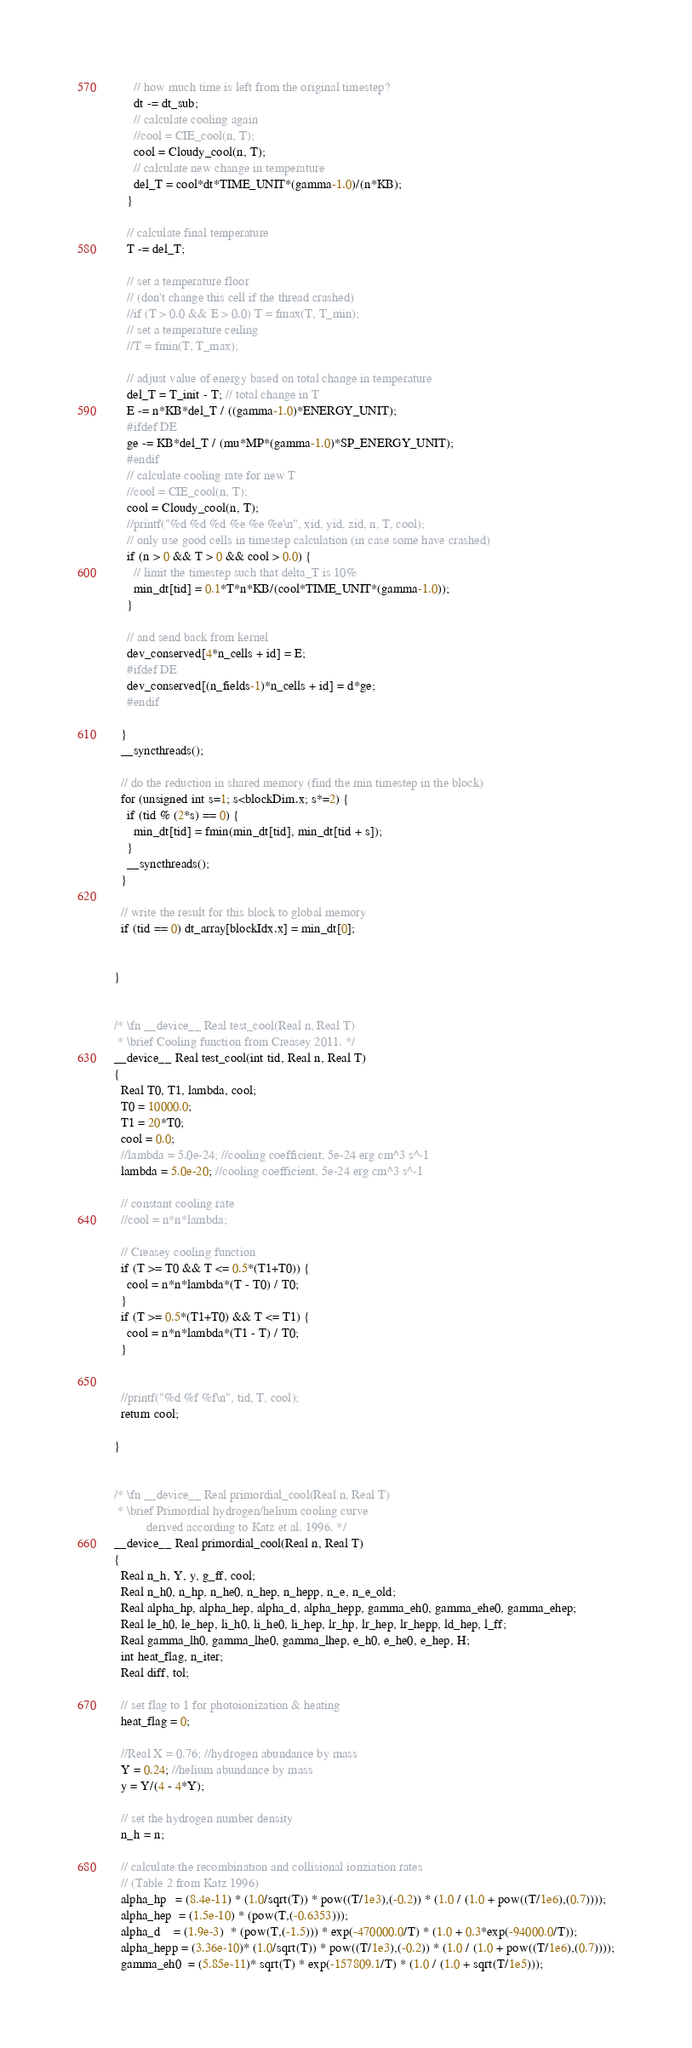<code> <loc_0><loc_0><loc_500><loc_500><_Cuda_>      // how much time is left from the original timestep?
      dt -= dt_sub;
      // calculate cooling again
      //cool = CIE_cool(n, T);
      cool = Cloudy_cool(n, T);
      // calculate new change in temperature
      del_T = cool*dt*TIME_UNIT*(gamma-1.0)/(n*KB);
    }

    // calculate final temperature
    T -= del_T;

    // set a temperature floor
    // (don't change this cell if the thread crashed)
    //if (T > 0.0 && E > 0.0) T = fmax(T, T_min);
    // set a temperature ceiling 
    //T = fmin(T, T_max);

    // adjust value of energy based on total change in temperature
    del_T = T_init - T; // total change in T
    E -= n*KB*del_T / ((gamma-1.0)*ENERGY_UNIT);
    #ifdef DE
    ge -= KB*del_T / (mu*MP*(gamma-1.0)*SP_ENERGY_UNIT);
    #endif
    // calculate cooling rate for new T
    //cool = CIE_cool(n, T);
    cool = Cloudy_cool(n, T);
    //printf("%d %d %d %e %e %e\n", xid, yid, zid, n, T, cool);
    // only use good cells in timestep calculation (in case some have crashed)
    if (n > 0 && T > 0 && cool > 0.0) {
      // limit the timestep such that delta_T is 10% 
      min_dt[tid] = 0.1*T*n*KB/(cool*TIME_UNIT*(gamma-1.0));
    }

    // and send back from kernel
    dev_conserved[4*n_cells + id] = E;
    #ifdef DE
    dev_conserved[(n_fields-1)*n_cells + id] = d*ge;
    #endif

  }
  __syncthreads();

  // do the reduction in shared memory (find the min timestep in the block)
  for (unsigned int s=1; s<blockDim.x; s*=2) {
    if (tid % (2*s) == 0) {
      min_dt[tid] = fmin(min_dt[tid], min_dt[tid + s]);
    }
    __syncthreads();
  }

  // write the result for this block to global memory
  if (tid == 0) dt_array[blockIdx.x] = min_dt[0];
  

}


/* \fn __device__ Real test_cool(Real n, Real T)
 * \brief Cooling function from Creasey 2011. */
__device__ Real test_cool(int tid, Real n, Real T)
{
  Real T0, T1, lambda, cool;
  T0 = 10000.0;
  T1 = 20*T0;
  cool = 0.0;
  //lambda = 5.0e-24; //cooling coefficient, 5e-24 erg cm^3 s^-1
  lambda = 5.0e-20; //cooling coefficient, 5e-24 erg cm^3 s^-1

  // constant cooling rate 
  //cool = n*n*lambda;

  // Creasey cooling function
  if (T >= T0 && T <= 0.5*(T1+T0)) {
    cool = n*n*lambda*(T - T0) / T0;
  }
  if (T >= 0.5*(T1+T0) && T <= T1) {
    cool = n*n*lambda*(T1 - T) / T0;
  }
 

  //printf("%d %f %f\n", tid, T, cool);
  return cool;

}


/* \fn __device__ Real primordial_cool(Real n, Real T)
 * \brief Primordial hydrogen/helium cooling curve 
          derived according to Katz et al. 1996. */
__device__ Real primordial_cool(Real n, Real T)
{
  Real n_h, Y, y, g_ff, cool;
  Real n_h0, n_hp, n_he0, n_hep, n_hepp, n_e, n_e_old; 
  Real alpha_hp, alpha_hep, alpha_d, alpha_hepp, gamma_eh0, gamma_ehe0, gamma_ehep;
  Real le_h0, le_hep, li_h0, li_he0, li_hep, lr_hp, lr_hep, lr_hepp, ld_hep, l_ff;
  Real gamma_lh0, gamma_lhe0, gamma_lhep, e_h0, e_he0, e_hep, H;
  int heat_flag, n_iter;
  Real diff, tol;

  // set flag to 1 for photoionization & heating
  heat_flag = 0;

  //Real X = 0.76; //hydrogen abundance by mass
  Y = 0.24; //helium abundance by mass
  y = Y/(4 - 4*Y);  

  // set the hydrogen number density 
  n_h = n; 

  // calculate the recombination and collisional ionziation rates
  // (Table 2 from Katz 1996)
  alpha_hp   = (8.4e-11) * (1.0/sqrt(T)) * pow((T/1e3),(-0.2)) * (1.0 / (1.0 + pow((T/1e6),(0.7))));
  alpha_hep  = (1.5e-10) * (pow(T,(-0.6353)));
  alpha_d    = (1.9e-3)  * (pow(T,(-1.5))) * exp(-470000.0/T) * (1.0 + 0.3*exp(-94000.0/T));
  alpha_hepp = (3.36e-10)* (1.0/sqrt(T)) * pow((T/1e3),(-0.2)) * (1.0 / (1.0 + pow((T/1e6),(0.7))));
  gamma_eh0  = (5.85e-11)* sqrt(T) * exp(-157809.1/T) * (1.0 / (1.0 + sqrt(T/1e5)));</code> 